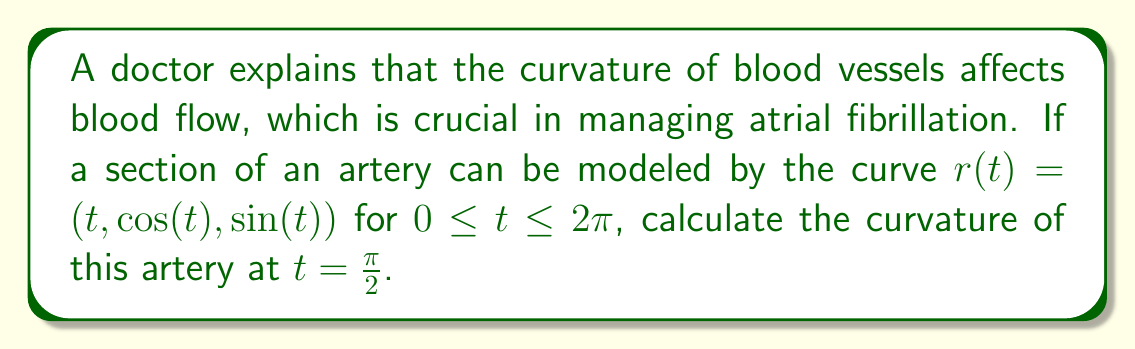Could you help me with this problem? To calculate the curvature of the blood vessel, we'll use the formula for the curvature of a parametric curve:

$$\kappa = \frac{|\mathbf{r}'(t) \times \mathbf{r}''(t)|}{|\mathbf{r}'(t)|^3}$$

Step 1: Calculate $\mathbf{r}'(t)$
$$\mathbf{r}'(t) = (1, -\sin(t), \cos(t))$$

Step 2: Calculate $\mathbf{r}''(t)$
$$\mathbf{r}''(t) = (0, -\cos(t), -\sin(t))$$

Step 3: Calculate $\mathbf{r}'(t) \times \mathbf{r}''(t)$
$$\begin{align*}
\mathbf{r}'(t) \times \mathbf{r}''(t) &= \begin{vmatrix}
\mathbf{i} & \mathbf{j} & \mathbf{k} \\
1 & -\sin(t) & \cos(t) \\
0 & -\cos(t) & -\sin(t)
\end{vmatrix} \\
&= (-\sin^2(t) - \cos^2(t))\mathbf{i} + (-\sin(t))\mathbf{j} + (\cos(t))\mathbf{k} \\
&= -\mathbf{i} - \sin(t)\mathbf{j} + \cos(t)\mathbf{k}
\end{align*}$$

Step 4: Calculate $|\mathbf{r}'(t) \times \mathbf{r}''(t)|$
$$|\mathbf{r}'(t) \times \mathbf{r}''(t)| = \sqrt{1^2 + \sin^2(t) + \cos^2(t)} = \sqrt{2}$$

Step 5: Calculate $|\mathbf{r}'(t)|$
$$|\mathbf{r}'(t)| = \sqrt{1^2 + \sin^2(t) + \cos^2(t)} = \sqrt{2}$$

Step 6: Calculate the curvature at $t = \frac{\pi}{2}$
$$\kappa = \frac{|\mathbf{r}'(t) \times \mathbf{r}''(t)|}{|\mathbf{r}'(t)|^3} = \frac{\sqrt{2}}{(\sqrt{2})^3} = \frac{\sqrt{2}}{2\sqrt{2}} = \frac{1}{2}$$

Therefore, the curvature of the blood vessel at $t = \frac{\pi}{2}$ is $\frac{1}{2}$.
Answer: $\frac{1}{2}$ 